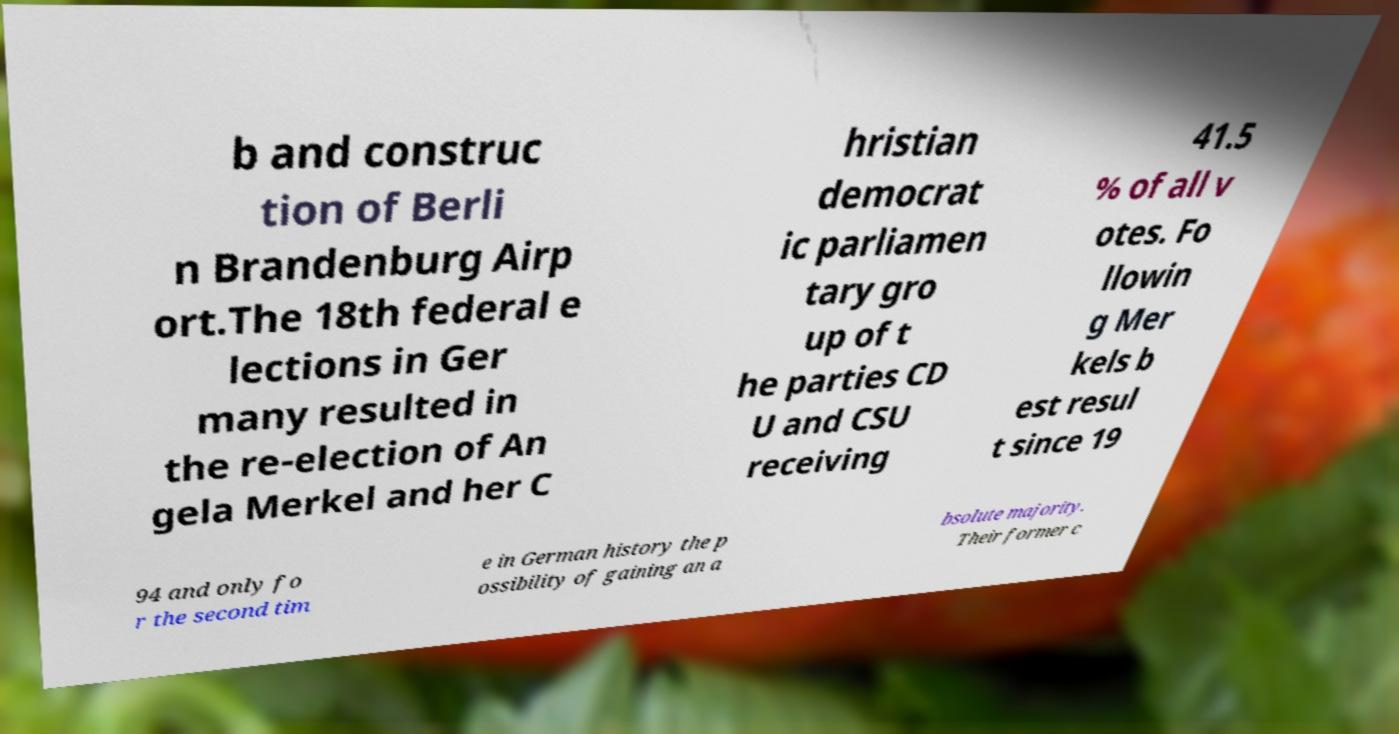Can you read and provide the text displayed in the image?This photo seems to have some interesting text. Can you extract and type it out for me? b and construc tion of Berli n Brandenburg Airp ort.The 18th federal e lections in Ger many resulted in the re-election of An gela Merkel and her C hristian democrat ic parliamen tary gro up of t he parties CD U and CSU receiving 41.5 % of all v otes. Fo llowin g Mer kels b est resul t since 19 94 and only fo r the second tim e in German history the p ossibility of gaining an a bsolute majority. Their former c 